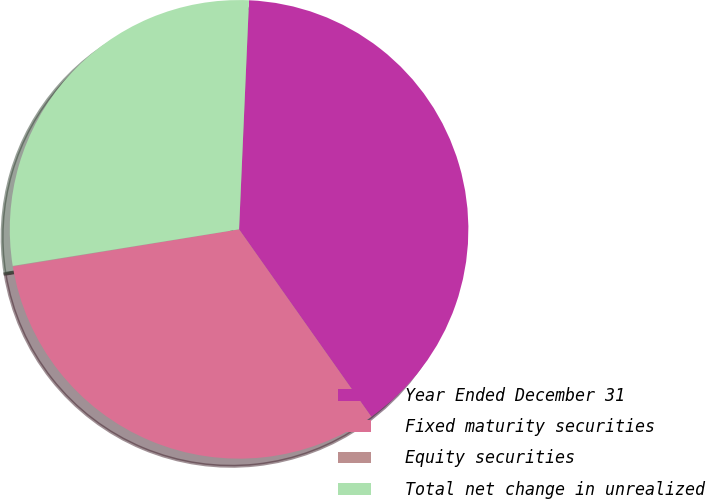Convert chart to OTSL. <chart><loc_0><loc_0><loc_500><loc_500><pie_chart><fcel>Year Ended December 31<fcel>Fixed maturity securities<fcel>Equity securities<fcel>Total net change in unrealized<nl><fcel>39.53%<fcel>32.19%<fcel>0.04%<fcel>28.24%<nl></chart> 